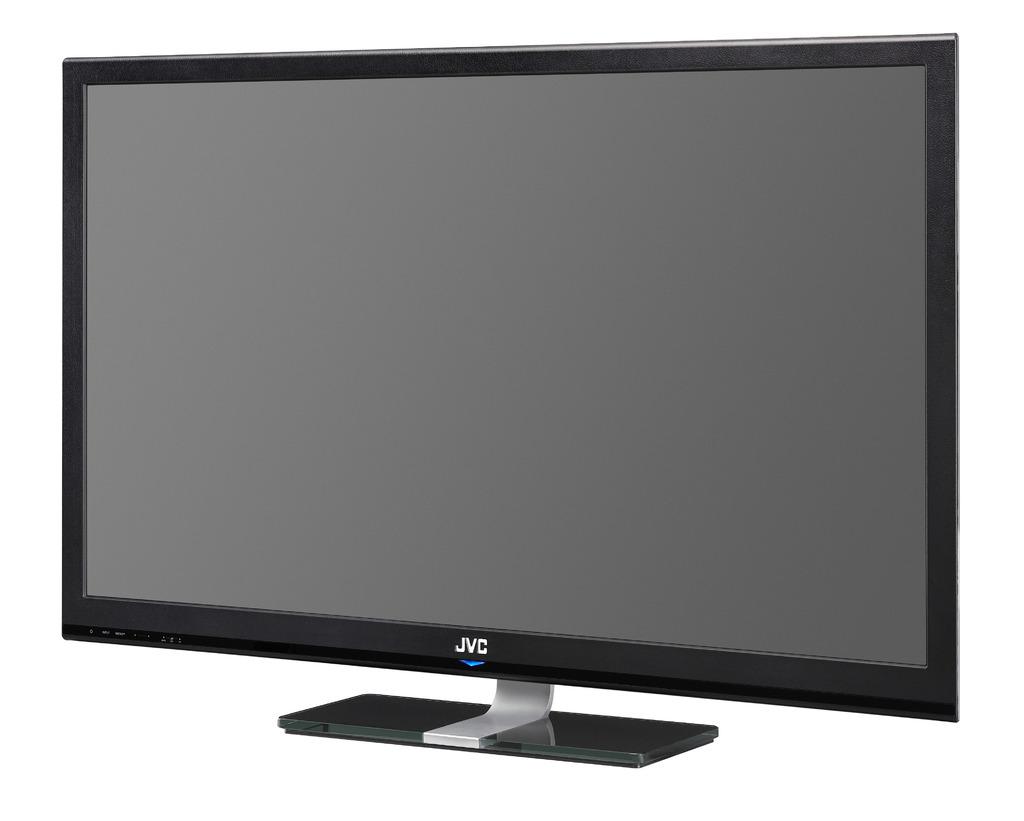Who makes this tv?
Keep it short and to the point. Jvc. 